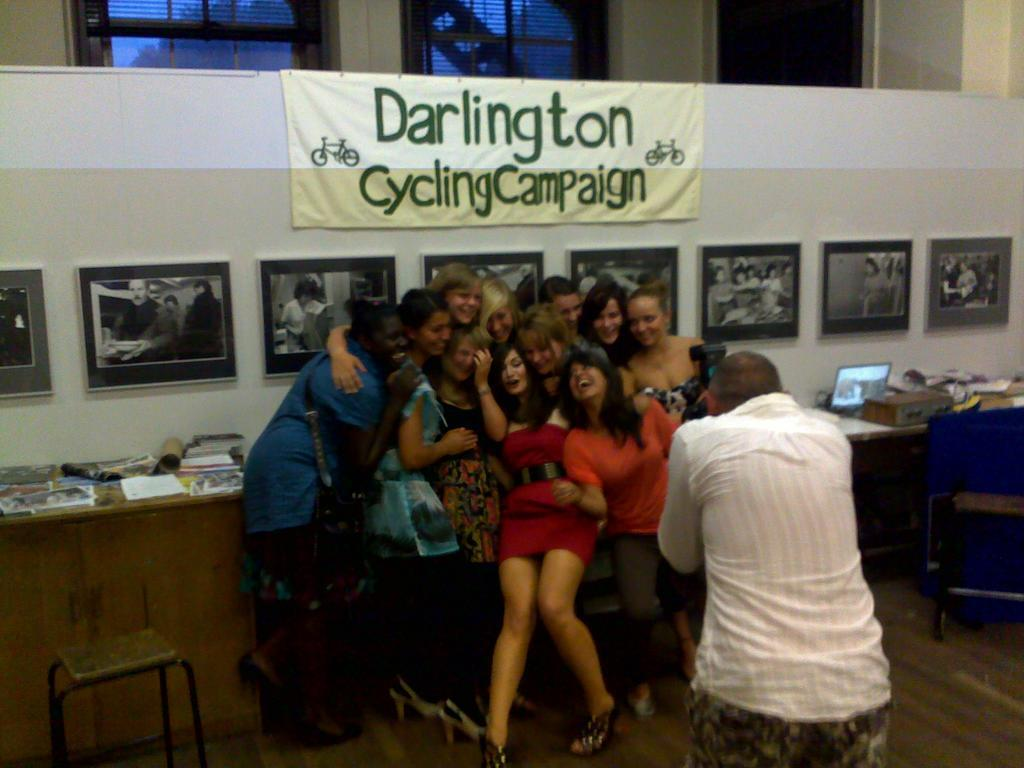How many people are in the image? There are people in the image, but the exact number is not specified. What is a person holding in the image? A person is holding a camera in the image. What can be seen on the wall in the image? There are frames on the wall in the image. What is visible through the windows in the image? There are windows in the image, but the view through them is not described. What is the purpose of the banner in the image? The purpose of the banner in the image is not specified. Can you see any goose playing the drum in the image? There is no goose or drum present in the image. Are there any fairies visible in the image? There is no mention of fairies in the image, so we cannot confirm their presence. 